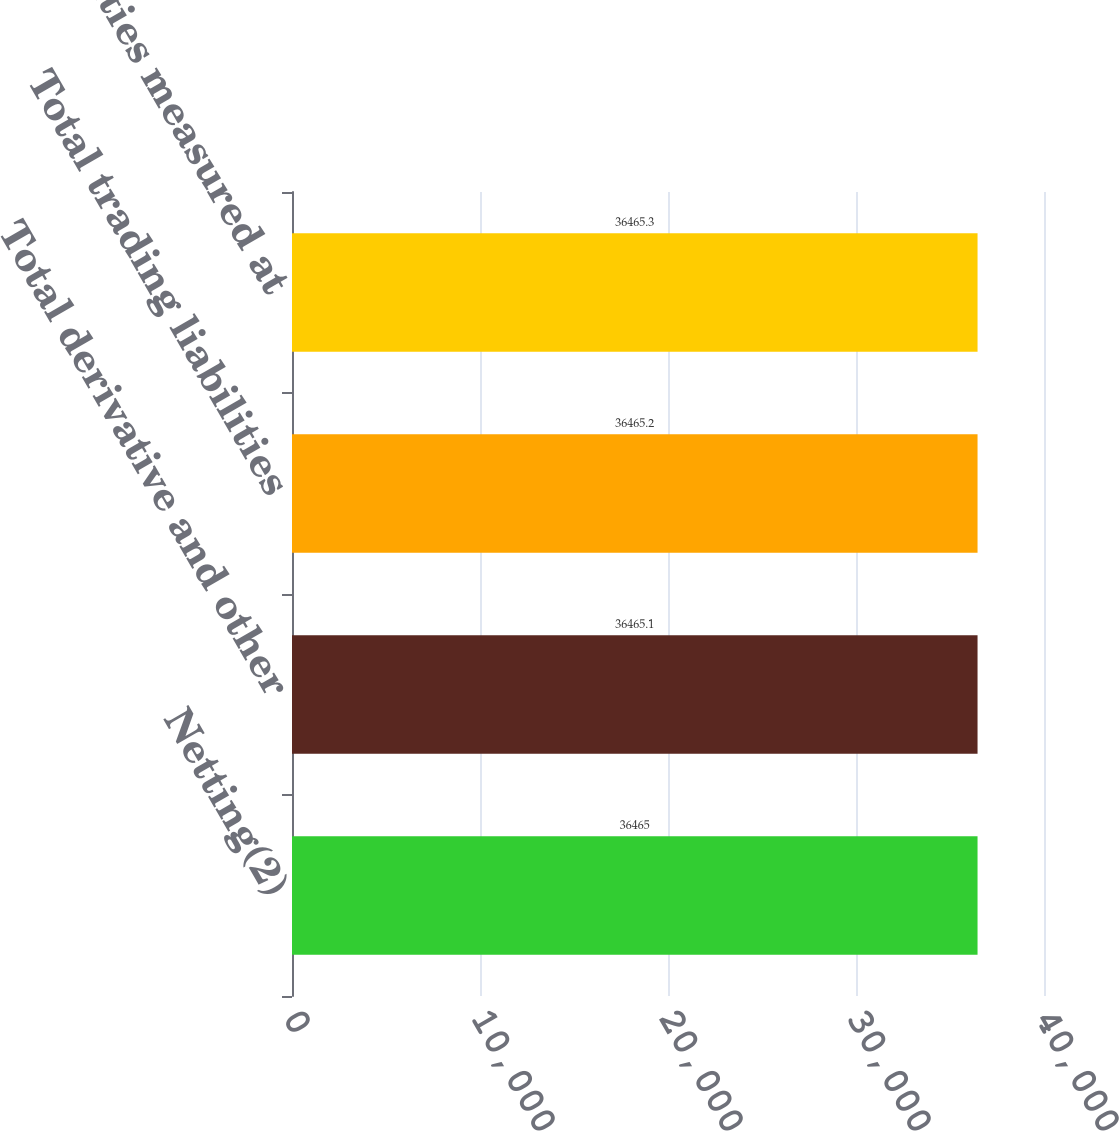Convert chart to OTSL. <chart><loc_0><loc_0><loc_500><loc_500><bar_chart><fcel>Netting(2)<fcel>Total derivative and other<fcel>Total trading liabilities<fcel>Total liabilities measured at<nl><fcel>36465<fcel>36465.1<fcel>36465.2<fcel>36465.3<nl></chart> 